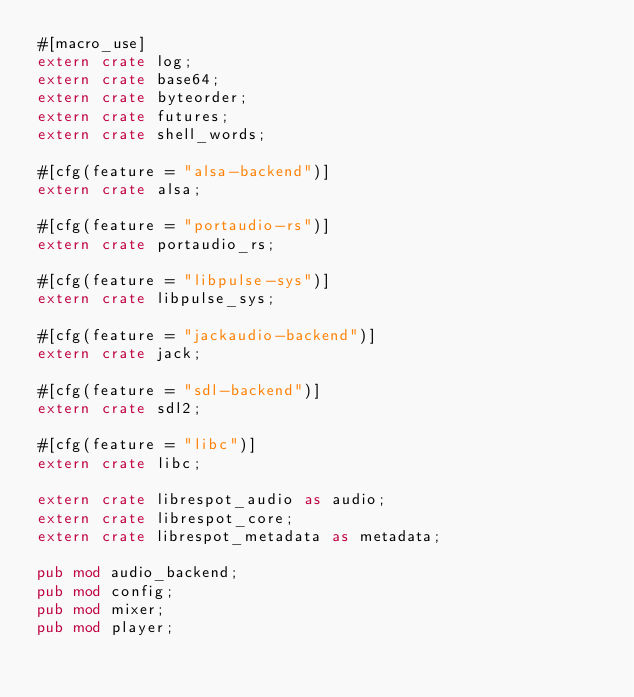Convert code to text. <code><loc_0><loc_0><loc_500><loc_500><_Rust_>#[macro_use]
extern crate log;
extern crate base64;
extern crate byteorder;
extern crate futures;
extern crate shell_words;

#[cfg(feature = "alsa-backend")]
extern crate alsa;

#[cfg(feature = "portaudio-rs")]
extern crate portaudio_rs;

#[cfg(feature = "libpulse-sys")]
extern crate libpulse_sys;

#[cfg(feature = "jackaudio-backend")]
extern crate jack;

#[cfg(feature = "sdl-backend")]
extern crate sdl2;

#[cfg(feature = "libc")]
extern crate libc;

extern crate librespot_audio as audio;
extern crate librespot_core;
extern crate librespot_metadata as metadata;

pub mod audio_backend;
pub mod config;
pub mod mixer;
pub mod player;
</code> 